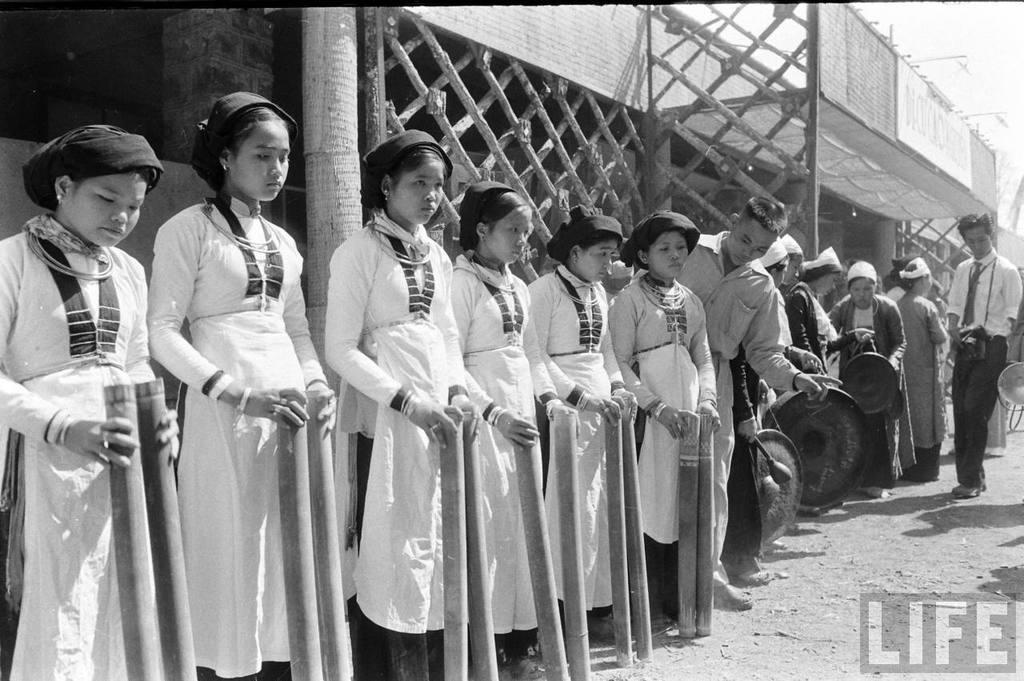Can you describe this image briefly? There are girls in the foreground holding bamboos in their hands and there are people on the right side, there is a wooden structure, poster and sky in the background area, there is text at the bottom side. 